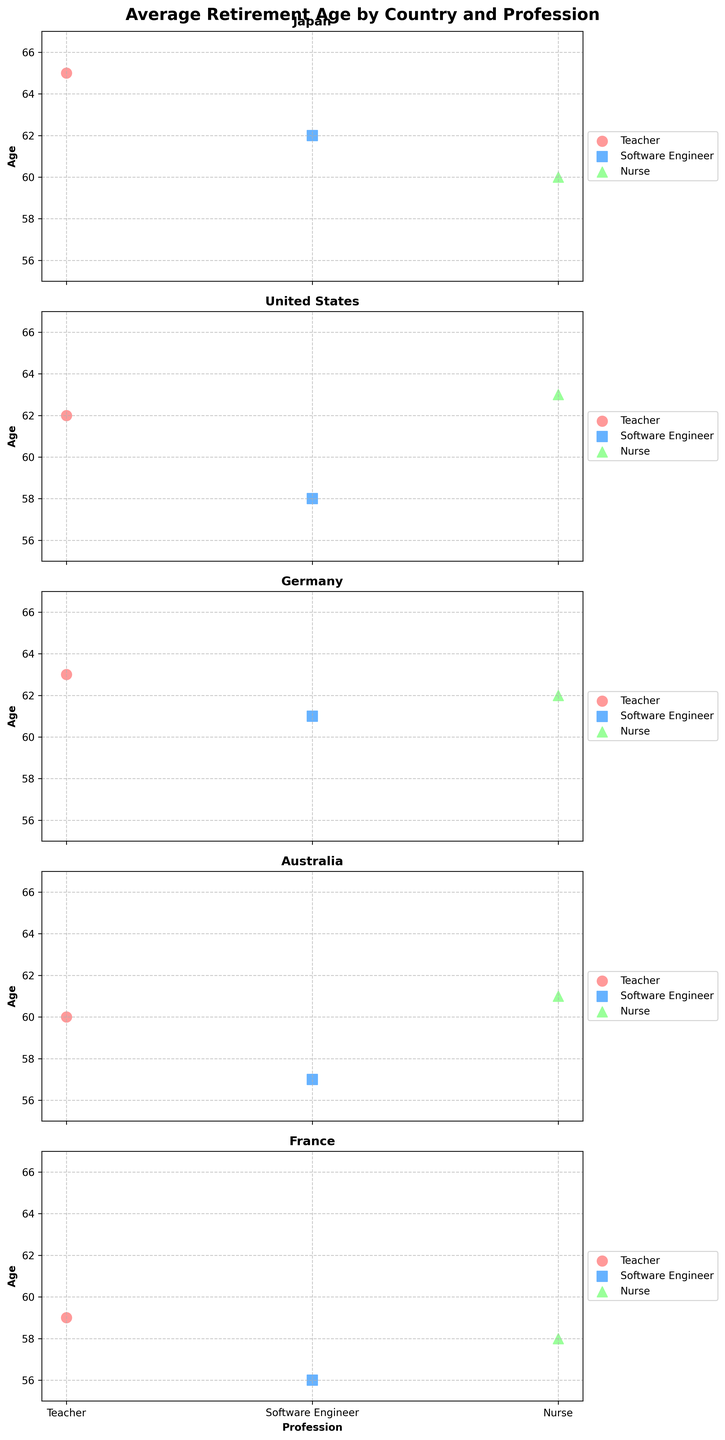What's the title of the figure? The title is located at the top of the figure. It reads "Average Retirement Age by Country and Profession."
Answer: Average Retirement Age by Country and Profession How many countries are compared in the figure? The figure is divided into multiple subplots, each one representing a different country. By counting the subplots, we can see there are five countries being compared.
Answer: 5 Which country has the highest average retirement age for nurses? To find this, we look at the subplots for all countries and identify the country where the average retirement age for nurses is the highest. In Japan, it's 60; in the United States, it's 63; in Germany, it's 62; in Australia, it's 61; and in France, it's 58.
Answer: United States What is the difference in average retirement age between teachers and software engineers in Australia? Find the retirement ages for both professions in the Australia subplot: Teachers retire at 60, Software Engineers retire at 57. The difference is 60 - 57.
Answer: 3 years Which country has the lowest average retirement age for software engineers? Look at the subplots for all countries and identify the retirement ages for software engineers. For Japan, it is 62; the United States, 58; Germany, 61; Australia, 57; and France, 56. The lowest is in France.
Answer: France Among the professions in Germany, which one has the closest average retirement age to 60? In Germany, the retirement ages are: Teacher 63, Software Engineer 61, and Nurse 62. The closest to 60 is the Software Engineer at 61.
Answer: Software Engineer How does the average retirement age for teachers in Japan compare to those in France? Look at the subplots for both Japan and France. In Japan, teachers retire at 65, while in France, they retire at 59. Comparing these two values, Japan has a higher retirement age for teachers.
Answer: Higher in Japan Which profession in the United States has the youngest average retirement age? Look at the United States subplot and check the retirement ages for each profession: Teachers 62, Software Engineers 58, and Nurses 63. The youngest retirement age is for Software Engineers.
Answer: Software Engineer What is the range of average retirement ages for nurses across all countries? Look at the retirement ages for nurses across all countries: Japan 60, United States 63, Germany 62, Australia 61, and France 58. The range is calculated as the highest value minus the lowest value, which is 63 - 58.
Answer: 5 years Are there any countries where the average retirement age of teachers is exactly the same as the average retirement age of nurses? Check each country's subplot to see if the retirement ages for teachers and nurses are the same. No countries have the same retirement age for these professions.
Answer: No 